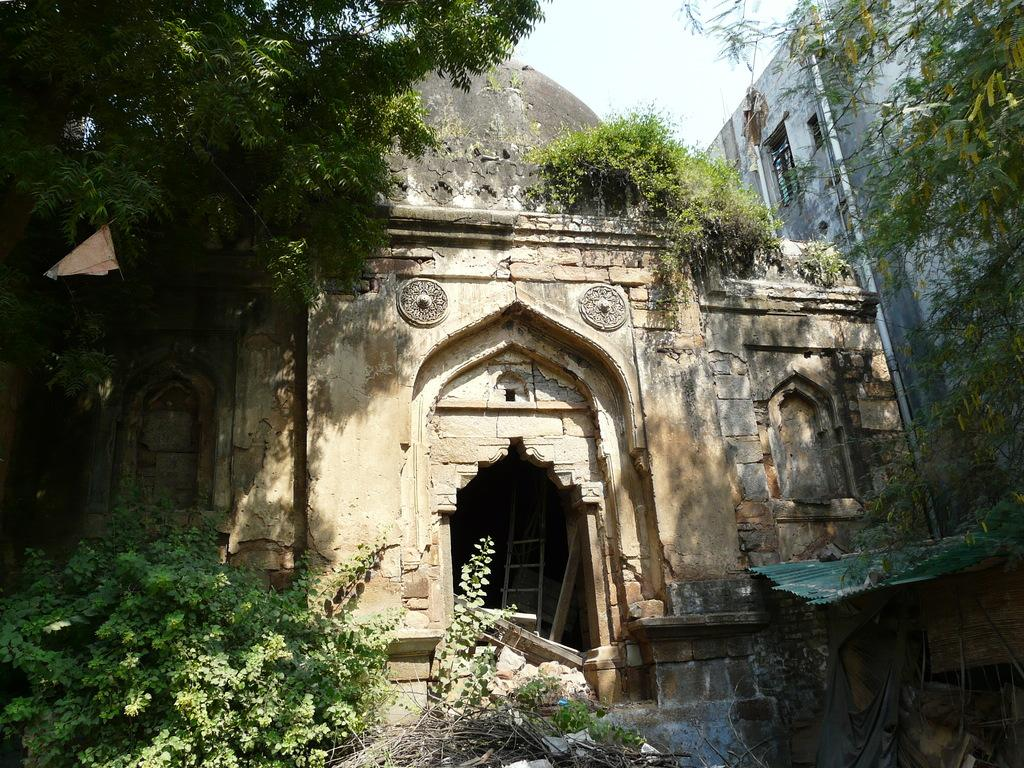What type of architecture is visible in the image? There is ancient architecture in the image. What structure can be seen in the image? There is a building in the image. What type of vegetation is present in the image? There are trees and plants in the image. What tool is visible in the image? There is a ladder in the image. What else can be seen in the image besides the architecture and vegetation? There are objects in the image. What is visible in the background of the image? The sky is visible in the background of the image. What type of banana is hanging from the ancient architecture in the image? There is no banana present in the image; it features ancient architecture, a building, trees, plants, a ladder, and objects. Can you see a woman wearing underwear in the image? There is no woman or underwear present in the image. 